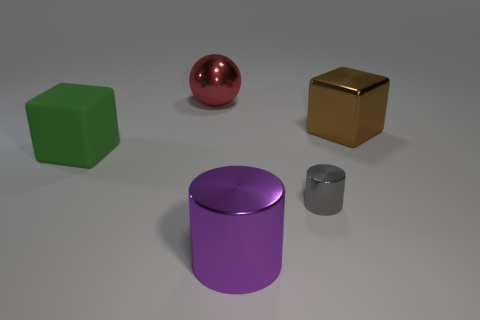Add 1 gray cylinders. How many objects exist? 6 Subtract all cubes. How many objects are left? 3 Subtract all big cyan balls. Subtract all metallic blocks. How many objects are left? 4 Add 2 green rubber cubes. How many green rubber cubes are left? 3 Add 3 shiny balls. How many shiny balls exist? 4 Subtract 1 gray cylinders. How many objects are left? 4 